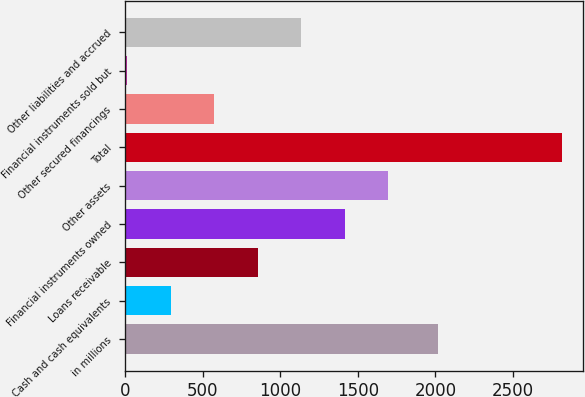<chart> <loc_0><loc_0><loc_500><loc_500><bar_chart><fcel>in millions<fcel>Cash and cash equivalents<fcel>Loans receivable<fcel>Financial instruments owned<fcel>Other assets<fcel>Total<fcel>Other secured financings<fcel>Financial instruments sold but<fcel>Other liabilities and accrued<nl><fcel>2017<fcel>294.8<fcel>854.4<fcel>1414<fcel>1693.8<fcel>2813<fcel>574.6<fcel>15<fcel>1134.2<nl></chart> 